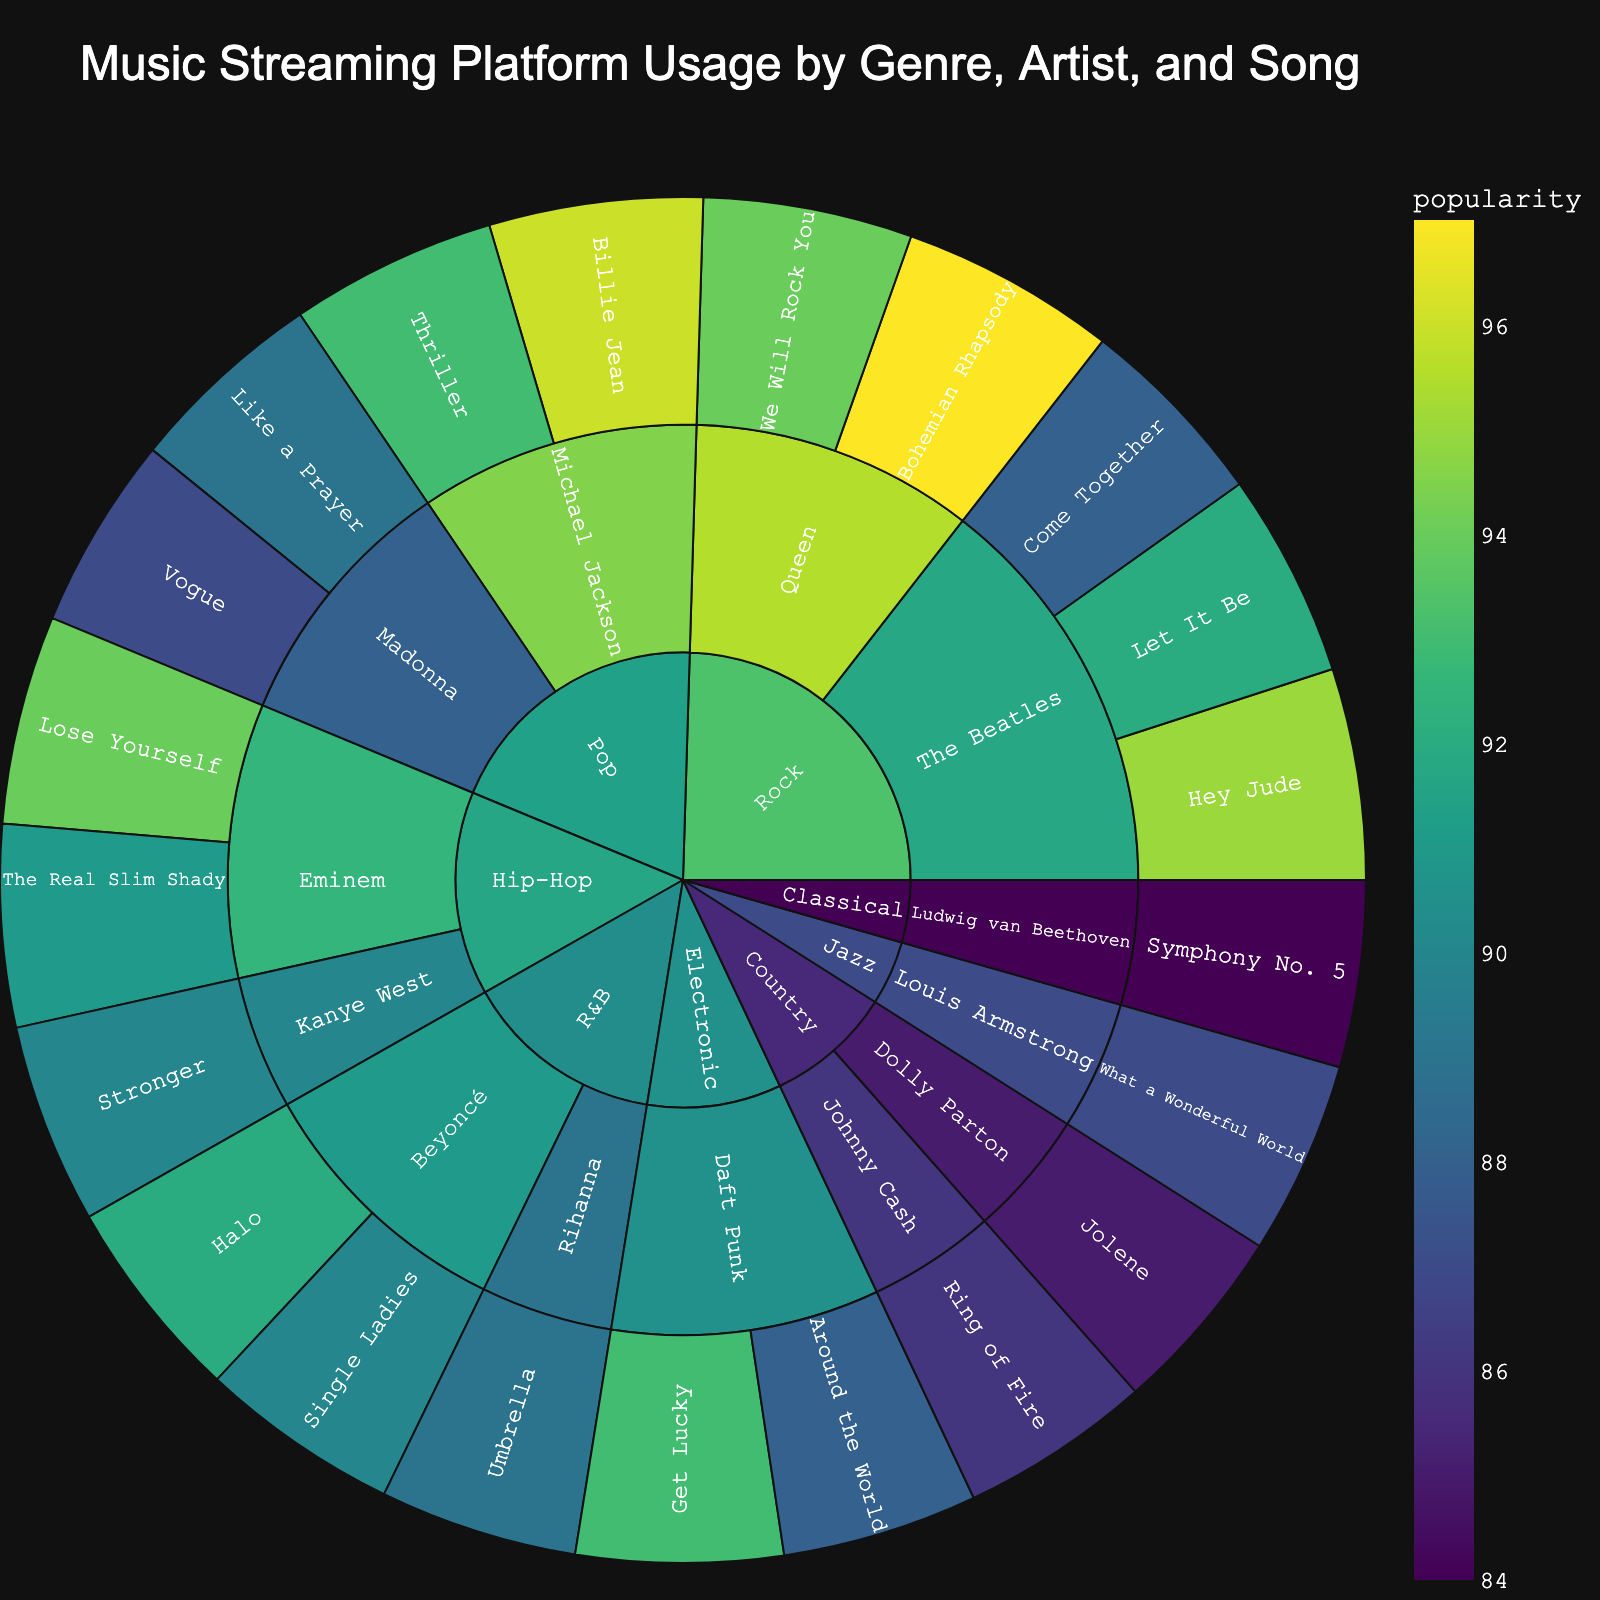How is the data organized in the Sunburst Plot? The data is organized hierarchically in the Sunburst Plot with three levels: genre, artist, and song. The outermost level represents the songs, the middle level represents the artists, and the center represents the genres.
Answer: Genre, Artist, Song Which genre has the highest overall popularity? By examining the Sunburst Plot, you can identify the genre with the most significant proportion of the plot and the highest total popularity based on the segment sizes.
Answer: Rock How many songs by Michael Jackson are included in the Sunburst Plot? Find the section dedicated to Michael Jackson under the Pop genre, and count the number of segments (songs) listed under his name.
Answer: 2 Which artist has the most songs listed under the Rock genre? Look at the Rock genre section and count the number of songs for each artist mentioned: The Beatles and Queen.
Answer: The Beatles What is the least popular song by Beyoncé in terms of popularity? Locate Beyoncé under R&B, and compare the popularity values for "Halo" and "Single Ladies" to determine the less popular one.
Answer: Single Ladies Which Pop song has the highest popularity? Identify the songs under the Pop genre and compare their popularity values to find the highest one: "Billie Jean" (96) and "Thriller" (93) by Michael Jackson, "Like a Prayer" (89) and "Vogue" (87) by Madonna.
Answer: Billie Jean Between the Jazz and Classical genres, which has the higher song popularity? Compare the popularity values of songs under the Jazz genre (Louis Armstrong's "What a Wonderful World" - 87) and the Classical genre (Beethoven's "Symphony No. 5" - 84).
Answer: Jazz What is the total popularity of songs by Daft Punk? Add the popularity values of Daft Punk's songs under the Electronic genre: "Get Lucky" (93) and "Around the World" (88).
Answer: 181 How does the popularity of "Bohemian Rhapsody" compare to "We Will Rock You"? Find these songs under Queen in the Rock genre and compare their popularity values: "Bohemian Rhapsody" (97) vs. "We Will Rock You" (94).
Answer: Bohemian Rhapsody is more popular Which genre has the fewest artists listed? Count the number of artists in each genre section, and identify the genre with the least: Classical (1), Jazz (1), Country (2), R&B (2), Electronic (1), Hip-Hop (2), Pop (2), Rock (2).
Answer: Classical, Jazz, and Electronic 